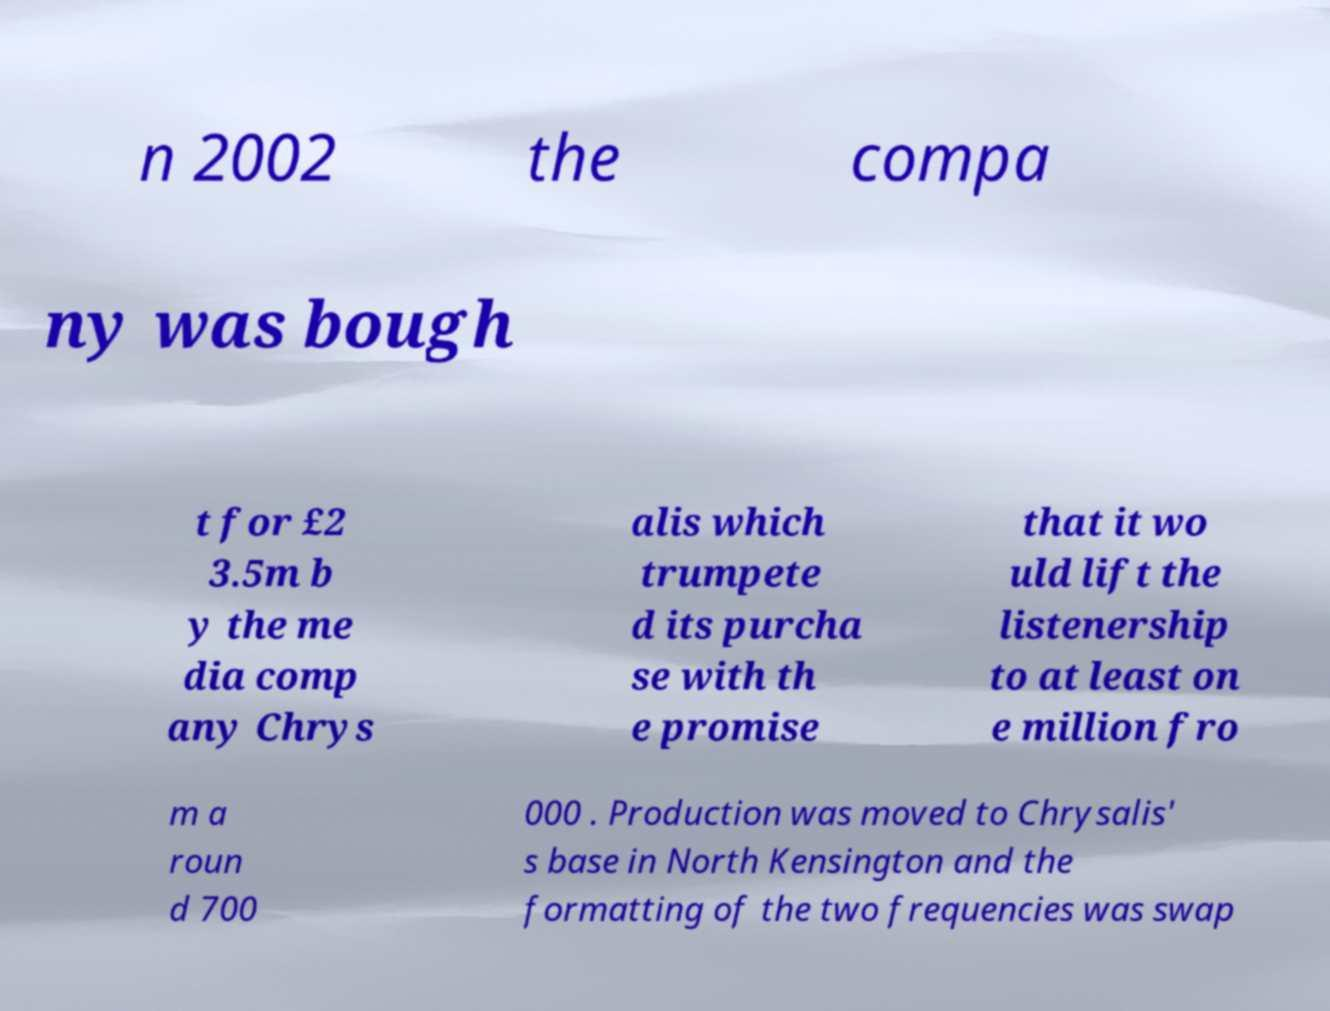Please read and relay the text visible in this image. What does it say? n 2002 the compa ny was bough t for £2 3.5m b y the me dia comp any Chrys alis which trumpete d its purcha se with th e promise that it wo uld lift the listenership to at least on e million fro m a roun d 700 000 . Production was moved to Chrysalis' s base in North Kensington and the formatting of the two frequencies was swap 